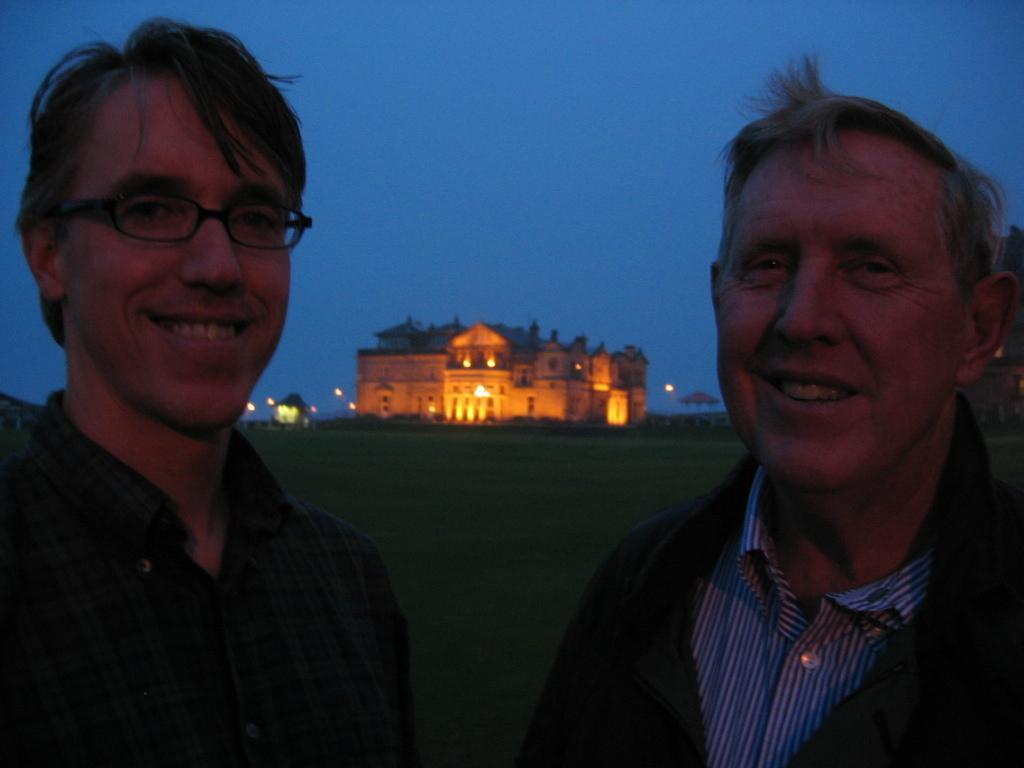Could you give a brief overview of what you see in this image? There are two men and smiling and we can see grass. Background we can see building,lights and sky. 